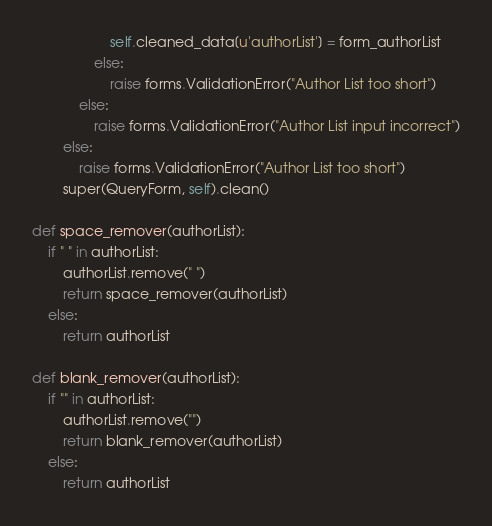<code> <loc_0><loc_0><loc_500><loc_500><_Python_>                    self.cleaned_data[u'authorList'] = form_authorList
                else:
                    raise forms.ValidationError("Author List too short")
            else:
                raise forms.ValidationError("Author List input incorrect")
        else:
            raise forms.ValidationError("Author List too short")
        super(QueryForm, self).clean()

def space_remover(authorList):
    if " " in authorList:
        authorList.remove(" ")
        return space_remover(authorList)
    else:
        return authorList

def blank_remover(authorList):
    if "" in authorList:
        authorList.remove("")
        return blank_remover(authorList)
    else:
        return authorList</code> 